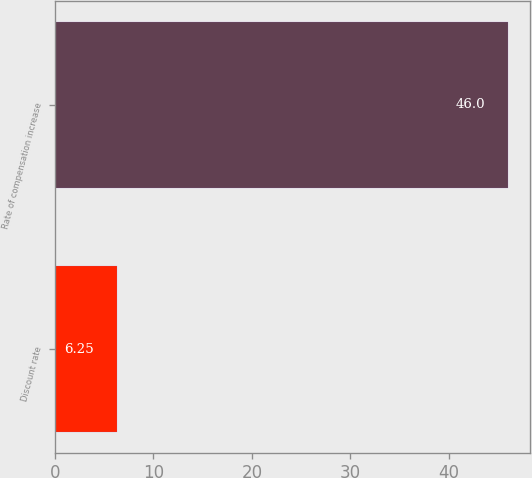Convert chart. <chart><loc_0><loc_0><loc_500><loc_500><bar_chart><fcel>Discount rate<fcel>Rate of compensation increase<nl><fcel>6.25<fcel>46<nl></chart> 